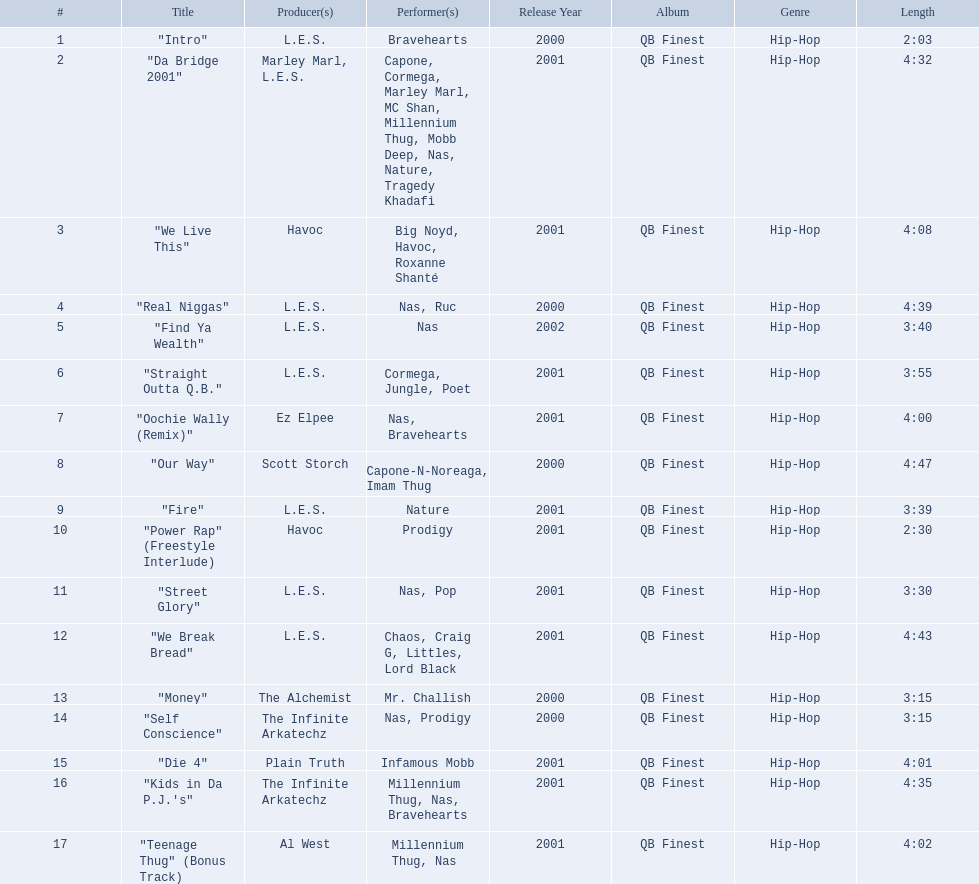What are all the songs on the album? "Intro", "Da Bridge 2001", "We Live This", "Real Niggas", "Find Ya Wealth", "Straight Outta Q.B.", "Oochie Wally (Remix)", "Our Way", "Fire", "Power Rap" (Freestyle Interlude), "Street Glory", "We Break Bread", "Money", "Self Conscience", "Die 4", "Kids in Da P.J.'s", "Teenage Thug" (Bonus Track). Which is the shortest? "Intro". How long is that song? 2:03. What are the track lengths on the album? 2:03, 4:32, 4:08, 4:39, 3:40, 3:55, 4:00, 4:47, 3:39, 2:30, 3:30, 4:43, 3:15, 3:15, 4:01, 4:35, 4:02. What is the longest length? 4:47. 